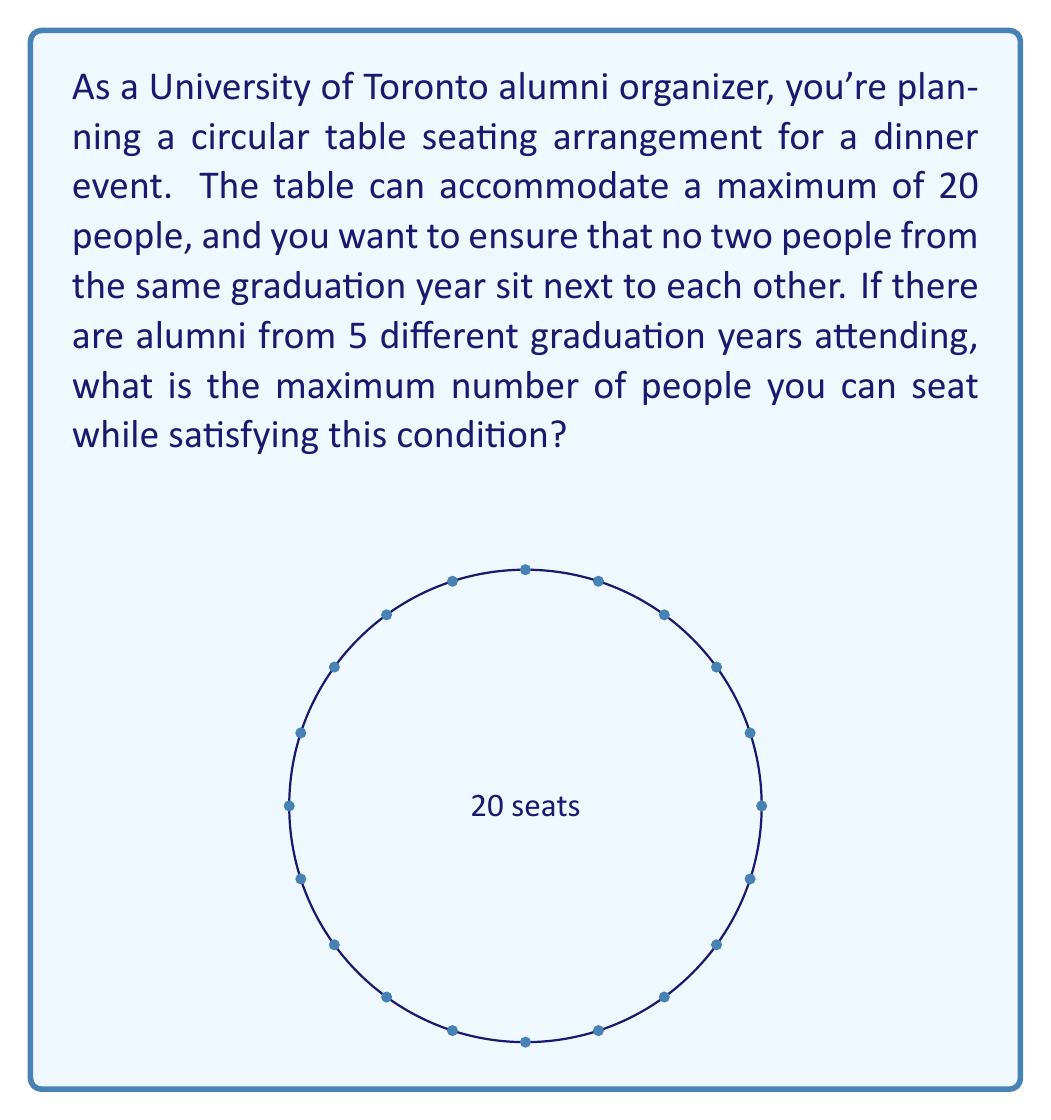What is the answer to this math problem? Let's approach this step-by-step:

1) First, we need to understand that this problem is similar to the "necklace arrangement" or "circular permutation" problem.

2) To ensure no two people from the same graduation year sit next to each other, we need to arrange the alumni in a pattern where each person is from a different year than their neighbors.

3) The maximum pattern that satisfies this condition would be a repeating sequence of all 5 years. Let's call this sequence ABCDE, where each letter represents a different graduation year.

4) This sequence (ABCDE) can be repeated around the table. The question is, how many times can we repeat it within 20 seats?

5) To calculate this, we divide the total number of seats by the length of our sequence:

   $$\text{Number of repetitions} = \lfloor \frac{20}{5} \rfloor = 4$$

   Where $\lfloor \rfloor$ denotes the floor function (rounding down to the nearest integer).

6) This means we can fit 4 complete sequences of ABCDE around the table.

7) The total number of people we can seat is therefore:

   $$\text{Maximum number of people} = 4 \times 5 = 20$$

8) We can verify that this satisfies our condition: each person will have neighbors from different graduation years, and we've used all available seats.
Answer: 20 people 